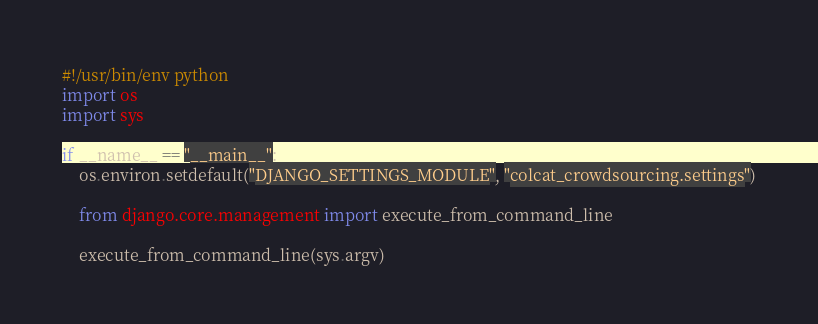<code> <loc_0><loc_0><loc_500><loc_500><_Python_>#!/usr/bin/env python
import os
import sys

if __name__ == "__main__":
    os.environ.setdefault("DJANGO_SETTINGS_MODULE", "colcat_crowdsourcing.settings")

    from django.core.management import execute_from_command_line

    execute_from_command_line(sys.argv)
</code> 